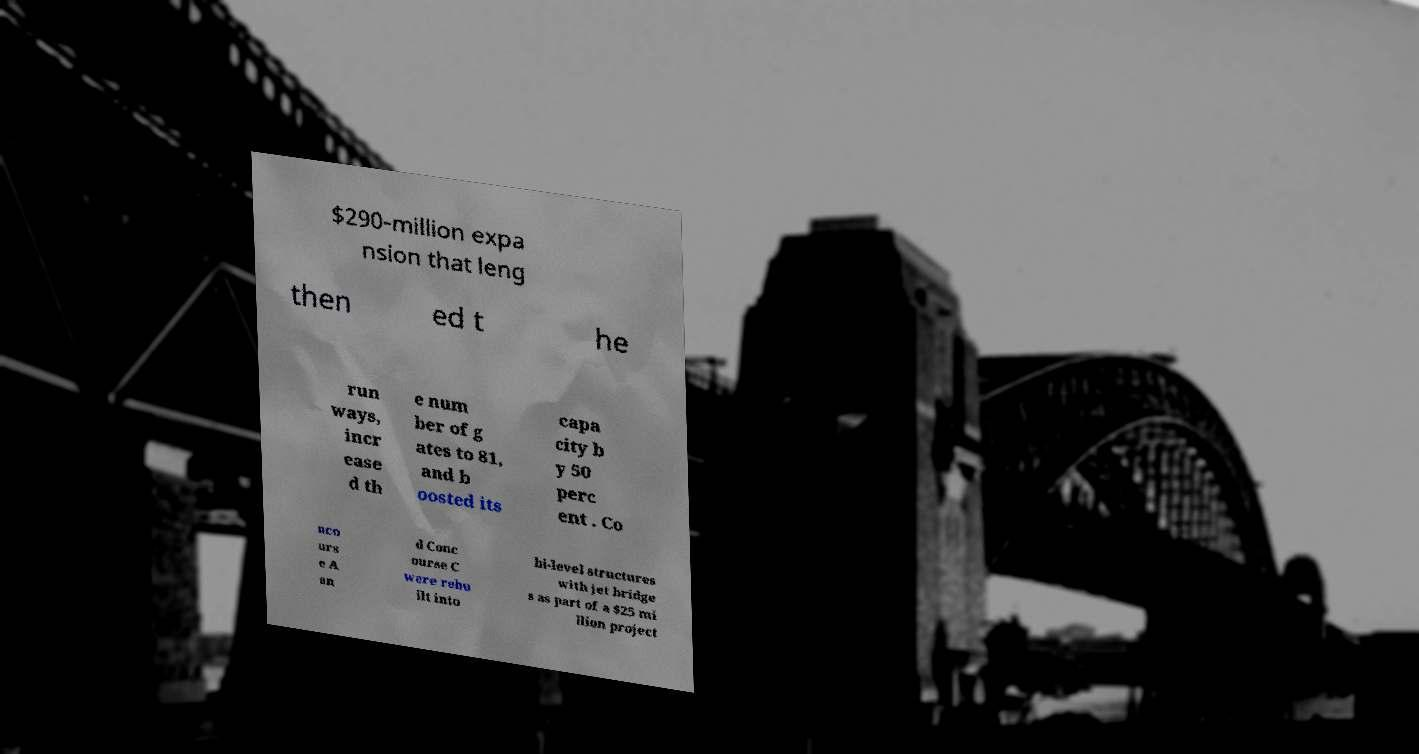For documentation purposes, I need the text within this image transcribed. Could you provide that? $290-million expa nsion that leng then ed t he run ways, incr ease d th e num ber of g ates to 81, and b oosted its capa city b y 50 perc ent . Co nco urs e A an d Conc ourse C were rebu ilt into bi-level structures with jet bridge s as part of a $25 mi llion project 